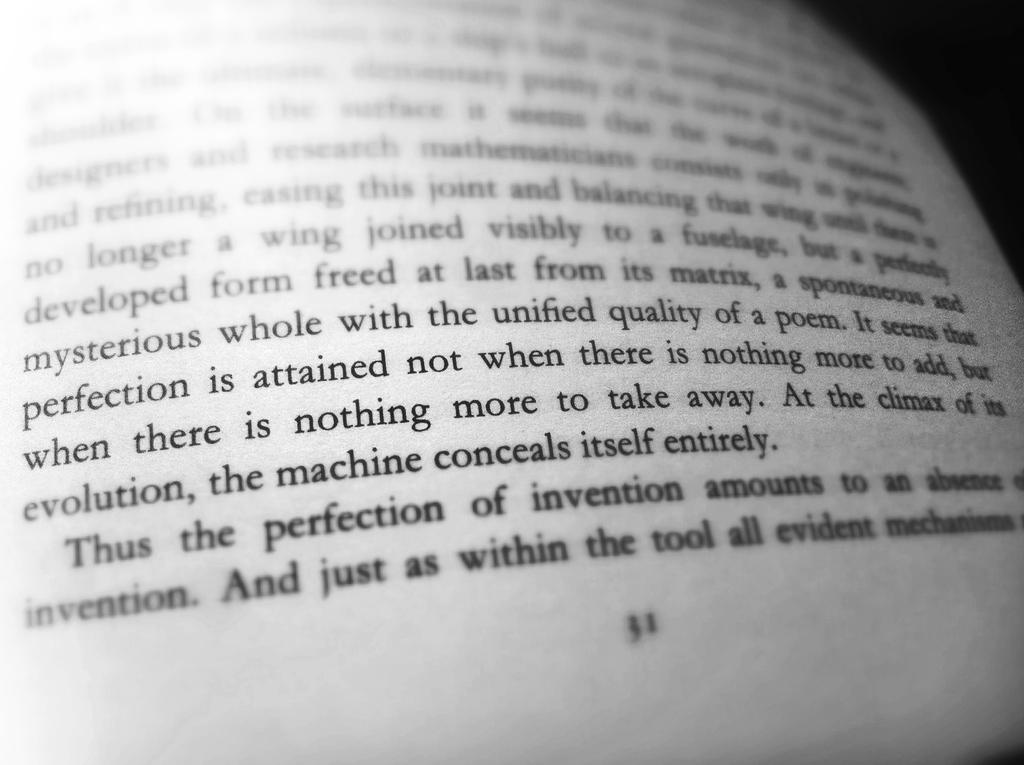<image>
Share a concise interpretation of the image provided. A closeup of page 31 of a book with lots of writing in it. 